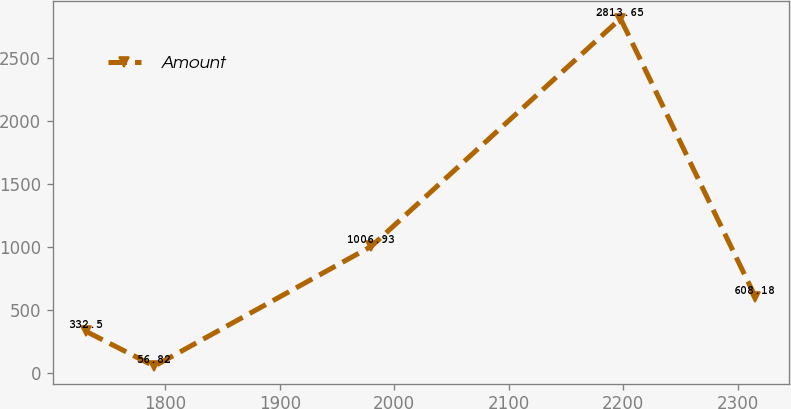Convert chart. <chart><loc_0><loc_0><loc_500><loc_500><line_chart><ecel><fcel>Amount<nl><fcel>1730.86<fcel>332.5<nl><fcel>1790.36<fcel>56.82<nl><fcel>1979.88<fcel>1006.93<nl><fcel>2197.55<fcel>2813.65<nl><fcel>2315.23<fcel>608.18<nl></chart> 